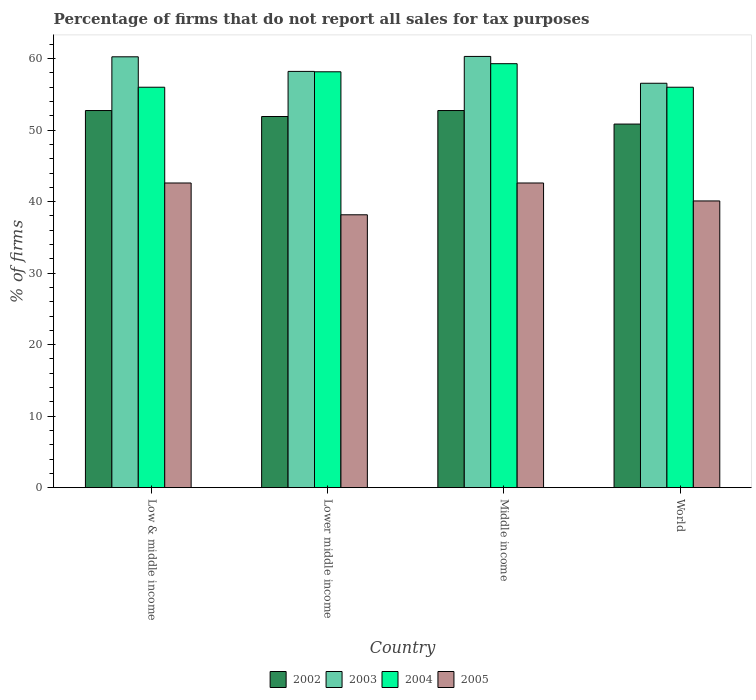How many different coloured bars are there?
Offer a terse response. 4. Are the number of bars per tick equal to the number of legend labels?
Your answer should be very brief. Yes. What is the percentage of firms that do not report all sales for tax purposes in 2003 in Low & middle income?
Give a very brief answer. 60.26. Across all countries, what is the maximum percentage of firms that do not report all sales for tax purposes in 2003?
Make the answer very short. 60.31. Across all countries, what is the minimum percentage of firms that do not report all sales for tax purposes in 2005?
Provide a succinct answer. 38.16. In which country was the percentage of firms that do not report all sales for tax purposes in 2002 maximum?
Your answer should be compact. Low & middle income. In which country was the percentage of firms that do not report all sales for tax purposes in 2004 minimum?
Provide a succinct answer. Low & middle income. What is the total percentage of firms that do not report all sales for tax purposes in 2004 in the graph?
Keep it short and to the point. 229.47. What is the difference between the percentage of firms that do not report all sales for tax purposes in 2004 in Low & middle income and that in World?
Provide a short and direct response. 0. What is the difference between the percentage of firms that do not report all sales for tax purposes in 2002 in Low & middle income and the percentage of firms that do not report all sales for tax purposes in 2005 in Lower middle income?
Ensure brevity in your answer.  14.58. What is the average percentage of firms that do not report all sales for tax purposes in 2004 per country?
Provide a short and direct response. 57.37. What is the difference between the percentage of firms that do not report all sales for tax purposes of/in 2002 and percentage of firms that do not report all sales for tax purposes of/in 2005 in World?
Your answer should be compact. 10.75. What is the ratio of the percentage of firms that do not report all sales for tax purposes in 2003 in Lower middle income to that in Middle income?
Provide a succinct answer. 0.97. Is the difference between the percentage of firms that do not report all sales for tax purposes in 2002 in Lower middle income and World greater than the difference between the percentage of firms that do not report all sales for tax purposes in 2005 in Lower middle income and World?
Ensure brevity in your answer.  Yes. What is the difference between the highest and the second highest percentage of firms that do not report all sales for tax purposes in 2002?
Offer a terse response. -0.84. What is the difference between the highest and the lowest percentage of firms that do not report all sales for tax purposes in 2003?
Offer a terse response. 3.75. In how many countries, is the percentage of firms that do not report all sales for tax purposes in 2005 greater than the average percentage of firms that do not report all sales for tax purposes in 2005 taken over all countries?
Keep it short and to the point. 2. Is it the case that in every country, the sum of the percentage of firms that do not report all sales for tax purposes in 2004 and percentage of firms that do not report all sales for tax purposes in 2003 is greater than the sum of percentage of firms that do not report all sales for tax purposes in 2002 and percentage of firms that do not report all sales for tax purposes in 2005?
Your answer should be very brief. Yes. What does the 3rd bar from the right in Low & middle income represents?
Your response must be concise. 2003. How many bars are there?
Ensure brevity in your answer.  16. Are all the bars in the graph horizontal?
Your answer should be compact. No. How many countries are there in the graph?
Provide a succinct answer. 4. What is the difference between two consecutive major ticks on the Y-axis?
Offer a terse response. 10. Does the graph contain any zero values?
Make the answer very short. No. Where does the legend appear in the graph?
Your answer should be very brief. Bottom center. How are the legend labels stacked?
Provide a short and direct response. Horizontal. What is the title of the graph?
Ensure brevity in your answer.  Percentage of firms that do not report all sales for tax purposes. Does "1976" appear as one of the legend labels in the graph?
Provide a succinct answer. No. What is the label or title of the Y-axis?
Your answer should be compact. % of firms. What is the % of firms of 2002 in Low & middle income?
Provide a succinct answer. 52.75. What is the % of firms of 2003 in Low & middle income?
Your response must be concise. 60.26. What is the % of firms of 2004 in Low & middle income?
Provide a succinct answer. 56.01. What is the % of firms in 2005 in Low & middle income?
Your response must be concise. 42.61. What is the % of firms of 2002 in Lower middle income?
Give a very brief answer. 51.91. What is the % of firms in 2003 in Lower middle income?
Your answer should be compact. 58.22. What is the % of firms in 2004 in Lower middle income?
Make the answer very short. 58.16. What is the % of firms in 2005 in Lower middle income?
Keep it short and to the point. 38.16. What is the % of firms of 2002 in Middle income?
Ensure brevity in your answer.  52.75. What is the % of firms in 2003 in Middle income?
Offer a terse response. 60.31. What is the % of firms of 2004 in Middle income?
Make the answer very short. 59.3. What is the % of firms in 2005 in Middle income?
Your response must be concise. 42.61. What is the % of firms in 2002 in World?
Your answer should be compact. 50.85. What is the % of firms in 2003 in World?
Give a very brief answer. 56.56. What is the % of firms of 2004 in World?
Your response must be concise. 56.01. What is the % of firms in 2005 in World?
Ensure brevity in your answer.  40.1. Across all countries, what is the maximum % of firms of 2002?
Your response must be concise. 52.75. Across all countries, what is the maximum % of firms in 2003?
Give a very brief answer. 60.31. Across all countries, what is the maximum % of firms in 2004?
Your answer should be compact. 59.3. Across all countries, what is the maximum % of firms of 2005?
Provide a succinct answer. 42.61. Across all countries, what is the minimum % of firms in 2002?
Keep it short and to the point. 50.85. Across all countries, what is the minimum % of firms in 2003?
Your answer should be very brief. 56.56. Across all countries, what is the minimum % of firms of 2004?
Make the answer very short. 56.01. Across all countries, what is the minimum % of firms of 2005?
Keep it short and to the point. 38.16. What is the total % of firms of 2002 in the graph?
Make the answer very short. 208.25. What is the total % of firms in 2003 in the graph?
Your response must be concise. 235.35. What is the total % of firms of 2004 in the graph?
Your response must be concise. 229.47. What is the total % of firms of 2005 in the graph?
Provide a succinct answer. 163.48. What is the difference between the % of firms of 2002 in Low & middle income and that in Lower middle income?
Your answer should be compact. 0.84. What is the difference between the % of firms of 2003 in Low & middle income and that in Lower middle income?
Give a very brief answer. 2.04. What is the difference between the % of firms in 2004 in Low & middle income and that in Lower middle income?
Ensure brevity in your answer.  -2.16. What is the difference between the % of firms of 2005 in Low & middle income and that in Lower middle income?
Keep it short and to the point. 4.45. What is the difference between the % of firms of 2002 in Low & middle income and that in Middle income?
Offer a very short reply. 0. What is the difference between the % of firms in 2003 in Low & middle income and that in Middle income?
Provide a succinct answer. -0.05. What is the difference between the % of firms in 2004 in Low & middle income and that in Middle income?
Make the answer very short. -3.29. What is the difference between the % of firms in 2002 in Low & middle income and that in World?
Your answer should be very brief. 1.89. What is the difference between the % of firms of 2004 in Low & middle income and that in World?
Give a very brief answer. 0. What is the difference between the % of firms in 2005 in Low & middle income and that in World?
Your response must be concise. 2.51. What is the difference between the % of firms of 2002 in Lower middle income and that in Middle income?
Your answer should be compact. -0.84. What is the difference between the % of firms in 2003 in Lower middle income and that in Middle income?
Your answer should be very brief. -2.09. What is the difference between the % of firms of 2004 in Lower middle income and that in Middle income?
Offer a very short reply. -1.13. What is the difference between the % of firms in 2005 in Lower middle income and that in Middle income?
Offer a very short reply. -4.45. What is the difference between the % of firms in 2002 in Lower middle income and that in World?
Your answer should be very brief. 1.06. What is the difference between the % of firms of 2003 in Lower middle income and that in World?
Your response must be concise. 1.66. What is the difference between the % of firms of 2004 in Lower middle income and that in World?
Offer a terse response. 2.16. What is the difference between the % of firms of 2005 in Lower middle income and that in World?
Ensure brevity in your answer.  -1.94. What is the difference between the % of firms in 2002 in Middle income and that in World?
Provide a succinct answer. 1.89. What is the difference between the % of firms of 2003 in Middle income and that in World?
Provide a succinct answer. 3.75. What is the difference between the % of firms in 2004 in Middle income and that in World?
Your answer should be very brief. 3.29. What is the difference between the % of firms in 2005 in Middle income and that in World?
Provide a short and direct response. 2.51. What is the difference between the % of firms of 2002 in Low & middle income and the % of firms of 2003 in Lower middle income?
Offer a very short reply. -5.47. What is the difference between the % of firms in 2002 in Low & middle income and the % of firms in 2004 in Lower middle income?
Give a very brief answer. -5.42. What is the difference between the % of firms in 2002 in Low & middle income and the % of firms in 2005 in Lower middle income?
Your answer should be very brief. 14.58. What is the difference between the % of firms in 2003 in Low & middle income and the % of firms in 2004 in Lower middle income?
Provide a succinct answer. 2.1. What is the difference between the % of firms in 2003 in Low & middle income and the % of firms in 2005 in Lower middle income?
Make the answer very short. 22.1. What is the difference between the % of firms of 2004 in Low & middle income and the % of firms of 2005 in Lower middle income?
Provide a succinct answer. 17.84. What is the difference between the % of firms in 2002 in Low & middle income and the % of firms in 2003 in Middle income?
Give a very brief answer. -7.57. What is the difference between the % of firms of 2002 in Low & middle income and the % of firms of 2004 in Middle income?
Make the answer very short. -6.55. What is the difference between the % of firms of 2002 in Low & middle income and the % of firms of 2005 in Middle income?
Provide a short and direct response. 10.13. What is the difference between the % of firms in 2003 in Low & middle income and the % of firms in 2004 in Middle income?
Your answer should be very brief. 0.96. What is the difference between the % of firms of 2003 in Low & middle income and the % of firms of 2005 in Middle income?
Make the answer very short. 17.65. What is the difference between the % of firms in 2004 in Low & middle income and the % of firms in 2005 in Middle income?
Your answer should be very brief. 13.39. What is the difference between the % of firms in 2002 in Low & middle income and the % of firms in 2003 in World?
Offer a terse response. -3.81. What is the difference between the % of firms of 2002 in Low & middle income and the % of firms of 2004 in World?
Provide a succinct answer. -3.26. What is the difference between the % of firms in 2002 in Low & middle income and the % of firms in 2005 in World?
Offer a terse response. 12.65. What is the difference between the % of firms of 2003 in Low & middle income and the % of firms of 2004 in World?
Make the answer very short. 4.25. What is the difference between the % of firms in 2003 in Low & middle income and the % of firms in 2005 in World?
Keep it short and to the point. 20.16. What is the difference between the % of firms of 2004 in Low & middle income and the % of firms of 2005 in World?
Your answer should be very brief. 15.91. What is the difference between the % of firms in 2002 in Lower middle income and the % of firms in 2003 in Middle income?
Make the answer very short. -8.4. What is the difference between the % of firms in 2002 in Lower middle income and the % of firms in 2004 in Middle income?
Keep it short and to the point. -7.39. What is the difference between the % of firms in 2002 in Lower middle income and the % of firms in 2005 in Middle income?
Your answer should be very brief. 9.3. What is the difference between the % of firms of 2003 in Lower middle income and the % of firms of 2004 in Middle income?
Keep it short and to the point. -1.08. What is the difference between the % of firms of 2003 in Lower middle income and the % of firms of 2005 in Middle income?
Offer a terse response. 15.61. What is the difference between the % of firms of 2004 in Lower middle income and the % of firms of 2005 in Middle income?
Ensure brevity in your answer.  15.55. What is the difference between the % of firms in 2002 in Lower middle income and the % of firms in 2003 in World?
Offer a very short reply. -4.65. What is the difference between the % of firms of 2002 in Lower middle income and the % of firms of 2004 in World?
Give a very brief answer. -4.1. What is the difference between the % of firms of 2002 in Lower middle income and the % of firms of 2005 in World?
Ensure brevity in your answer.  11.81. What is the difference between the % of firms of 2003 in Lower middle income and the % of firms of 2004 in World?
Provide a short and direct response. 2.21. What is the difference between the % of firms of 2003 in Lower middle income and the % of firms of 2005 in World?
Offer a terse response. 18.12. What is the difference between the % of firms in 2004 in Lower middle income and the % of firms in 2005 in World?
Offer a terse response. 18.07. What is the difference between the % of firms in 2002 in Middle income and the % of firms in 2003 in World?
Your answer should be very brief. -3.81. What is the difference between the % of firms of 2002 in Middle income and the % of firms of 2004 in World?
Your answer should be compact. -3.26. What is the difference between the % of firms in 2002 in Middle income and the % of firms in 2005 in World?
Your response must be concise. 12.65. What is the difference between the % of firms in 2003 in Middle income and the % of firms in 2004 in World?
Make the answer very short. 4.31. What is the difference between the % of firms of 2003 in Middle income and the % of firms of 2005 in World?
Provide a short and direct response. 20.21. What is the difference between the % of firms of 2004 in Middle income and the % of firms of 2005 in World?
Ensure brevity in your answer.  19.2. What is the average % of firms of 2002 per country?
Offer a very short reply. 52.06. What is the average % of firms in 2003 per country?
Your answer should be very brief. 58.84. What is the average % of firms in 2004 per country?
Give a very brief answer. 57.37. What is the average % of firms of 2005 per country?
Ensure brevity in your answer.  40.87. What is the difference between the % of firms in 2002 and % of firms in 2003 in Low & middle income?
Offer a very short reply. -7.51. What is the difference between the % of firms in 2002 and % of firms in 2004 in Low & middle income?
Your answer should be very brief. -3.26. What is the difference between the % of firms in 2002 and % of firms in 2005 in Low & middle income?
Provide a short and direct response. 10.13. What is the difference between the % of firms of 2003 and % of firms of 2004 in Low & middle income?
Your response must be concise. 4.25. What is the difference between the % of firms of 2003 and % of firms of 2005 in Low & middle income?
Your response must be concise. 17.65. What is the difference between the % of firms of 2004 and % of firms of 2005 in Low & middle income?
Your answer should be very brief. 13.39. What is the difference between the % of firms in 2002 and % of firms in 2003 in Lower middle income?
Your answer should be very brief. -6.31. What is the difference between the % of firms in 2002 and % of firms in 2004 in Lower middle income?
Make the answer very short. -6.26. What is the difference between the % of firms in 2002 and % of firms in 2005 in Lower middle income?
Your answer should be compact. 13.75. What is the difference between the % of firms in 2003 and % of firms in 2004 in Lower middle income?
Offer a very short reply. 0.05. What is the difference between the % of firms of 2003 and % of firms of 2005 in Lower middle income?
Your answer should be compact. 20.06. What is the difference between the % of firms of 2004 and % of firms of 2005 in Lower middle income?
Your answer should be compact. 20. What is the difference between the % of firms of 2002 and % of firms of 2003 in Middle income?
Offer a very short reply. -7.57. What is the difference between the % of firms in 2002 and % of firms in 2004 in Middle income?
Offer a terse response. -6.55. What is the difference between the % of firms in 2002 and % of firms in 2005 in Middle income?
Give a very brief answer. 10.13. What is the difference between the % of firms in 2003 and % of firms in 2004 in Middle income?
Make the answer very short. 1.02. What is the difference between the % of firms of 2003 and % of firms of 2005 in Middle income?
Your response must be concise. 17.7. What is the difference between the % of firms of 2004 and % of firms of 2005 in Middle income?
Keep it short and to the point. 16.69. What is the difference between the % of firms of 2002 and % of firms of 2003 in World?
Keep it short and to the point. -5.71. What is the difference between the % of firms of 2002 and % of firms of 2004 in World?
Give a very brief answer. -5.15. What is the difference between the % of firms in 2002 and % of firms in 2005 in World?
Your response must be concise. 10.75. What is the difference between the % of firms of 2003 and % of firms of 2004 in World?
Offer a very short reply. 0.56. What is the difference between the % of firms in 2003 and % of firms in 2005 in World?
Your answer should be compact. 16.46. What is the difference between the % of firms in 2004 and % of firms in 2005 in World?
Provide a succinct answer. 15.91. What is the ratio of the % of firms in 2002 in Low & middle income to that in Lower middle income?
Your response must be concise. 1.02. What is the ratio of the % of firms in 2003 in Low & middle income to that in Lower middle income?
Make the answer very short. 1.04. What is the ratio of the % of firms of 2004 in Low & middle income to that in Lower middle income?
Make the answer very short. 0.96. What is the ratio of the % of firms in 2005 in Low & middle income to that in Lower middle income?
Offer a terse response. 1.12. What is the ratio of the % of firms of 2004 in Low & middle income to that in Middle income?
Provide a short and direct response. 0.94. What is the ratio of the % of firms of 2002 in Low & middle income to that in World?
Give a very brief answer. 1.04. What is the ratio of the % of firms of 2003 in Low & middle income to that in World?
Ensure brevity in your answer.  1.07. What is the ratio of the % of firms of 2005 in Low & middle income to that in World?
Your answer should be very brief. 1.06. What is the ratio of the % of firms in 2002 in Lower middle income to that in Middle income?
Make the answer very short. 0.98. What is the ratio of the % of firms of 2003 in Lower middle income to that in Middle income?
Your answer should be compact. 0.97. What is the ratio of the % of firms of 2004 in Lower middle income to that in Middle income?
Your answer should be compact. 0.98. What is the ratio of the % of firms in 2005 in Lower middle income to that in Middle income?
Your answer should be very brief. 0.9. What is the ratio of the % of firms in 2002 in Lower middle income to that in World?
Offer a very short reply. 1.02. What is the ratio of the % of firms in 2003 in Lower middle income to that in World?
Keep it short and to the point. 1.03. What is the ratio of the % of firms of 2004 in Lower middle income to that in World?
Keep it short and to the point. 1.04. What is the ratio of the % of firms in 2005 in Lower middle income to that in World?
Keep it short and to the point. 0.95. What is the ratio of the % of firms of 2002 in Middle income to that in World?
Offer a very short reply. 1.04. What is the ratio of the % of firms in 2003 in Middle income to that in World?
Provide a short and direct response. 1.07. What is the ratio of the % of firms in 2004 in Middle income to that in World?
Make the answer very short. 1.06. What is the ratio of the % of firms of 2005 in Middle income to that in World?
Make the answer very short. 1.06. What is the difference between the highest and the second highest % of firms of 2002?
Make the answer very short. 0. What is the difference between the highest and the second highest % of firms of 2003?
Your answer should be very brief. 0.05. What is the difference between the highest and the second highest % of firms of 2004?
Provide a succinct answer. 1.13. What is the difference between the highest and the lowest % of firms of 2002?
Offer a very short reply. 1.89. What is the difference between the highest and the lowest % of firms of 2003?
Offer a very short reply. 3.75. What is the difference between the highest and the lowest % of firms of 2004?
Provide a short and direct response. 3.29. What is the difference between the highest and the lowest % of firms of 2005?
Offer a terse response. 4.45. 